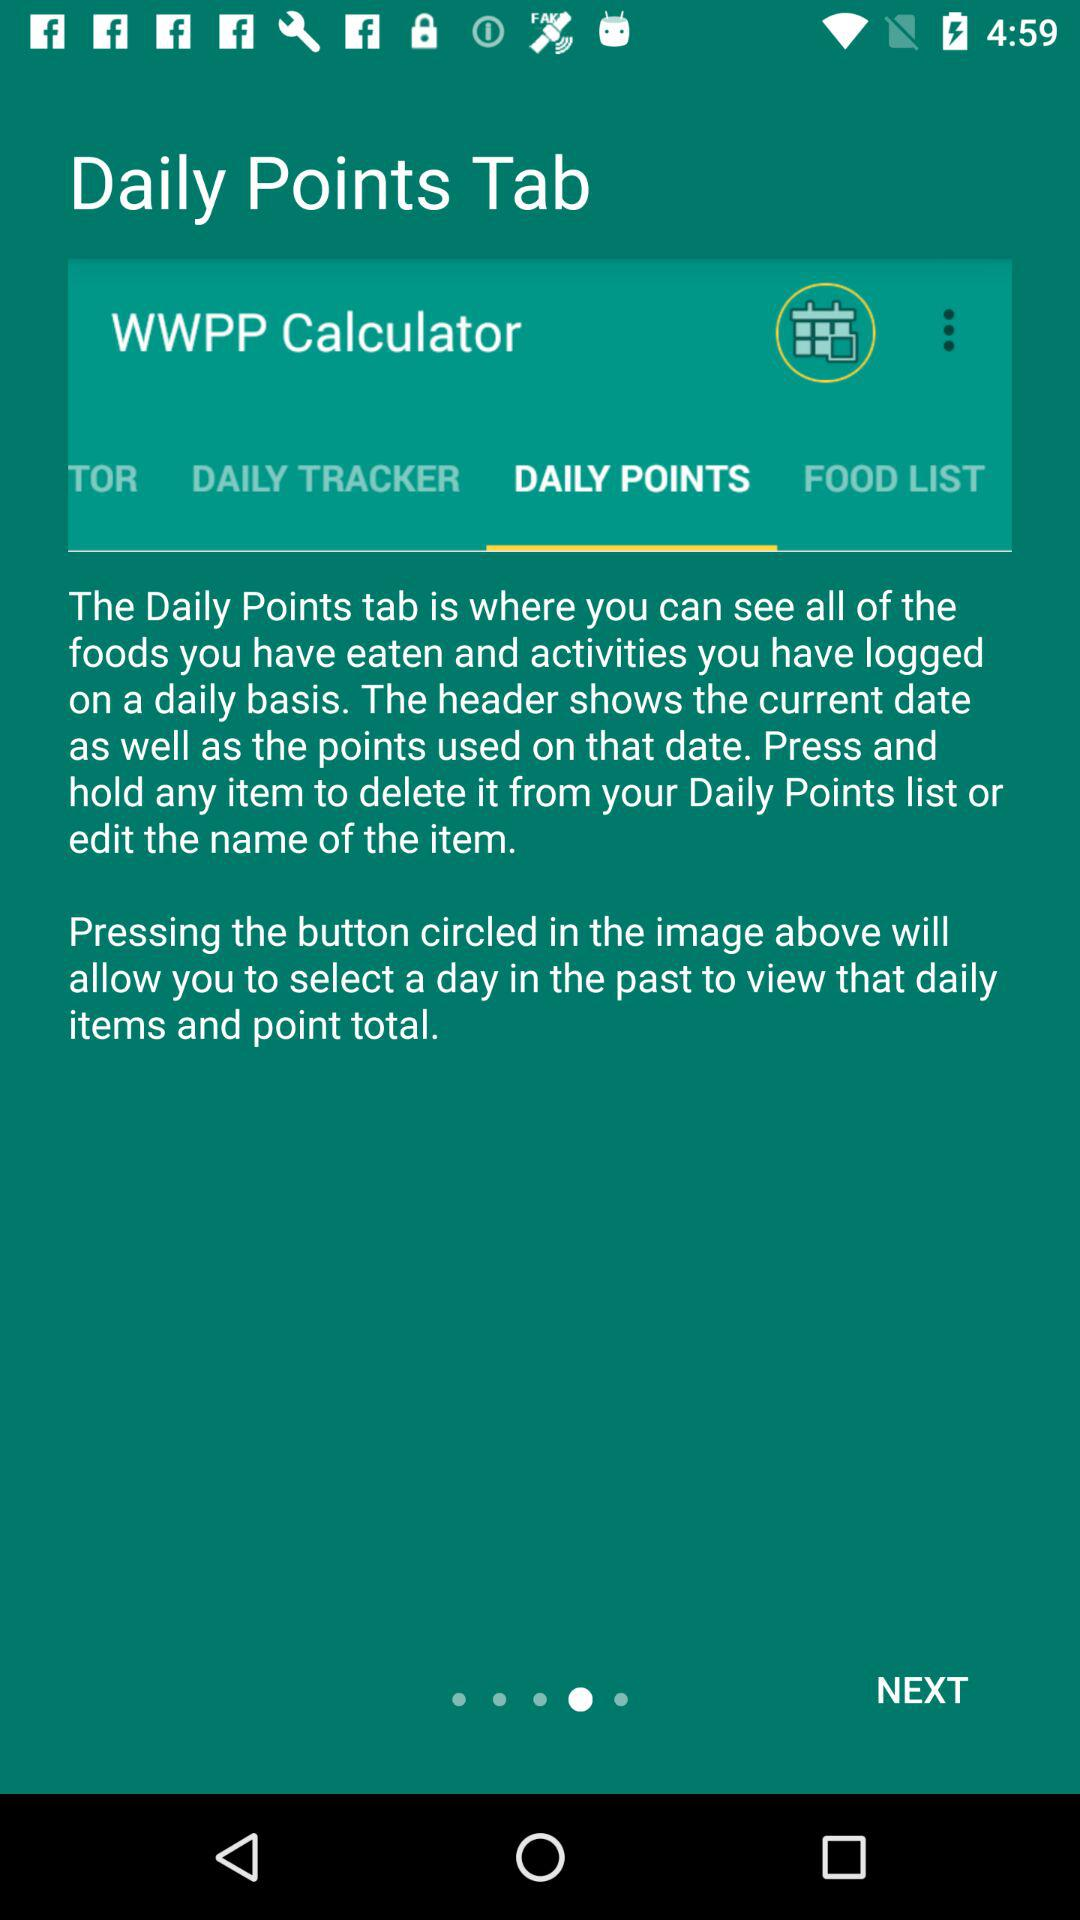Which tab is selected? The selected tab is "DAILY POINTS". 